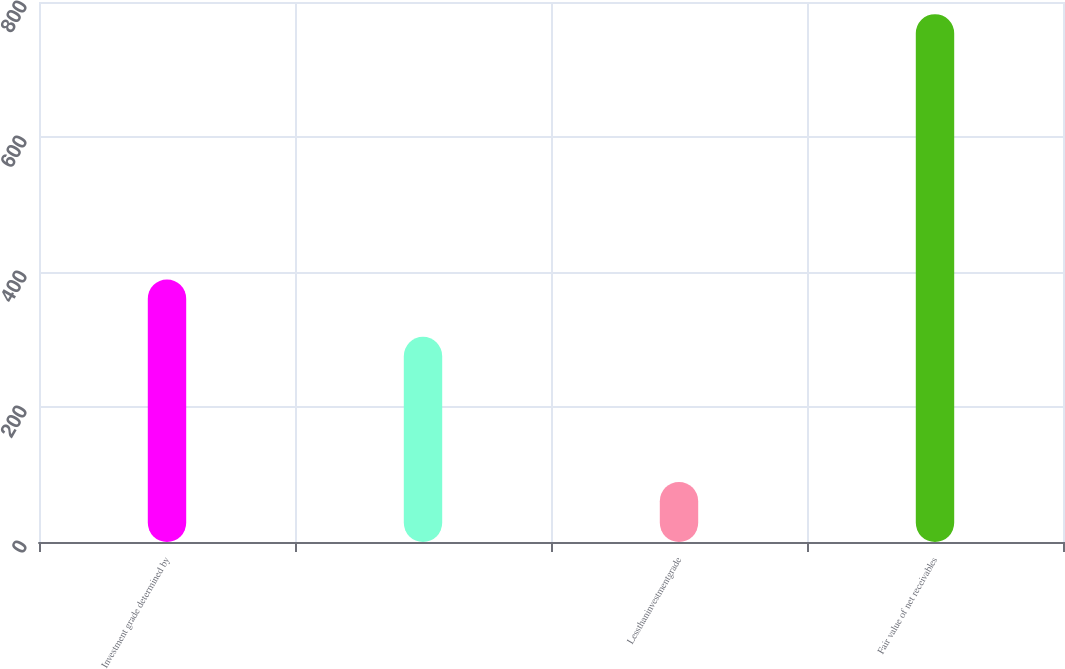<chart> <loc_0><loc_0><loc_500><loc_500><bar_chart><fcel>Investment grade determined by<fcel>Unnamed: 1<fcel>Lessthaninvestmentgrade<fcel>Fair value of net receivables<nl><fcel>389<fcel>304<fcel>89<fcel>782<nl></chart> 